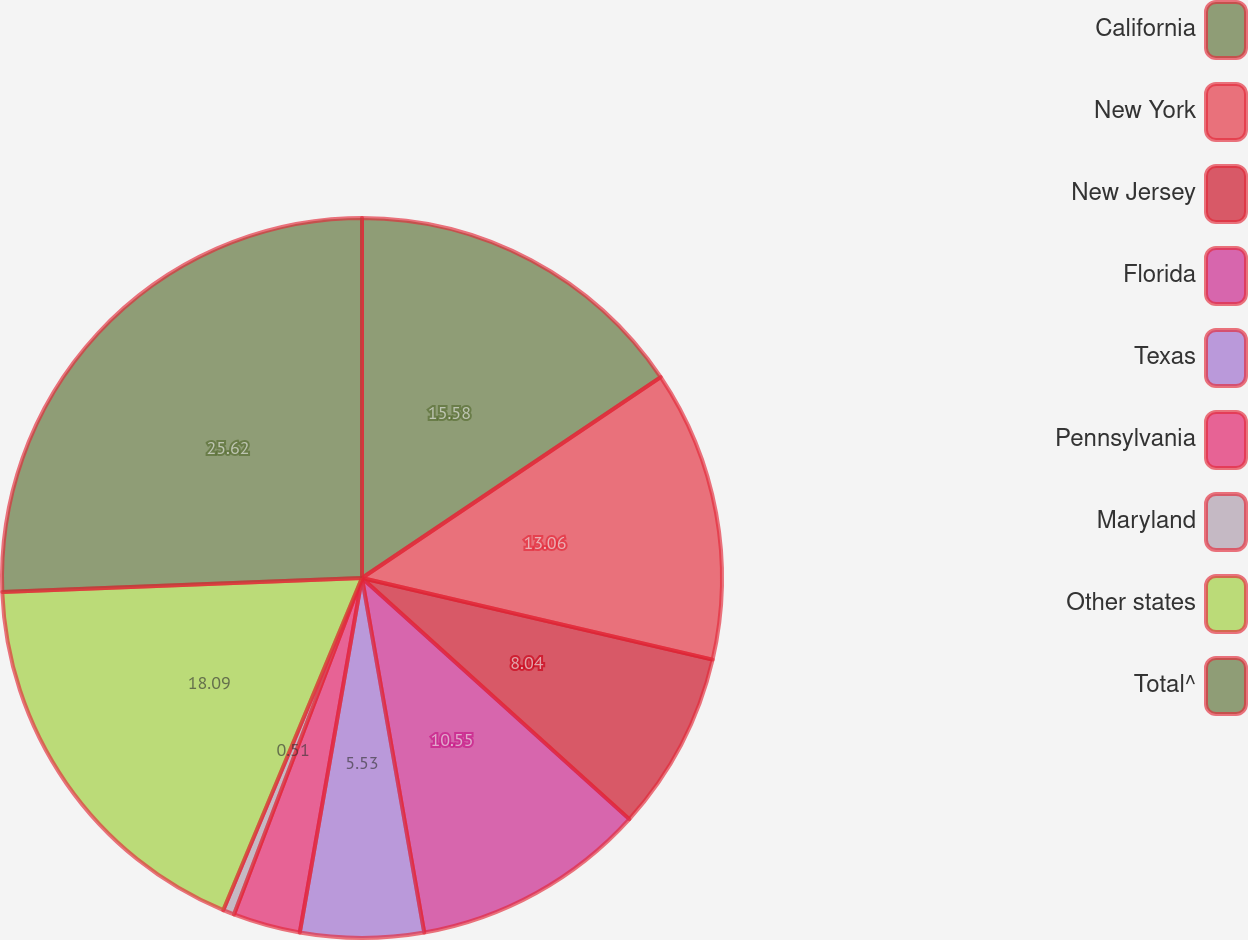Convert chart. <chart><loc_0><loc_0><loc_500><loc_500><pie_chart><fcel>California<fcel>New York<fcel>New Jersey<fcel>Florida<fcel>Texas<fcel>Pennsylvania<fcel>Maryland<fcel>Other states<fcel>Total^<nl><fcel>15.57%<fcel>13.06%<fcel>8.04%<fcel>10.55%<fcel>5.53%<fcel>3.02%<fcel>0.51%<fcel>18.08%<fcel>25.61%<nl></chart> 